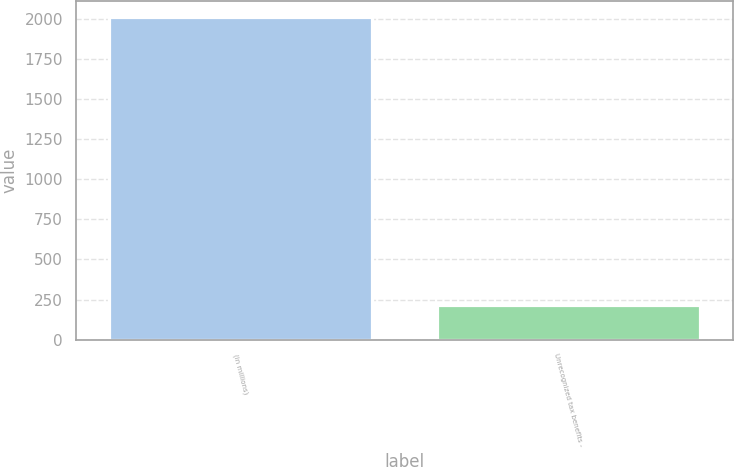Convert chart. <chart><loc_0><loc_0><loc_500><loc_500><bar_chart><fcel>(in millions)<fcel>Unrecognized tax benefits -<nl><fcel>2010<fcel>218.1<nl></chart> 